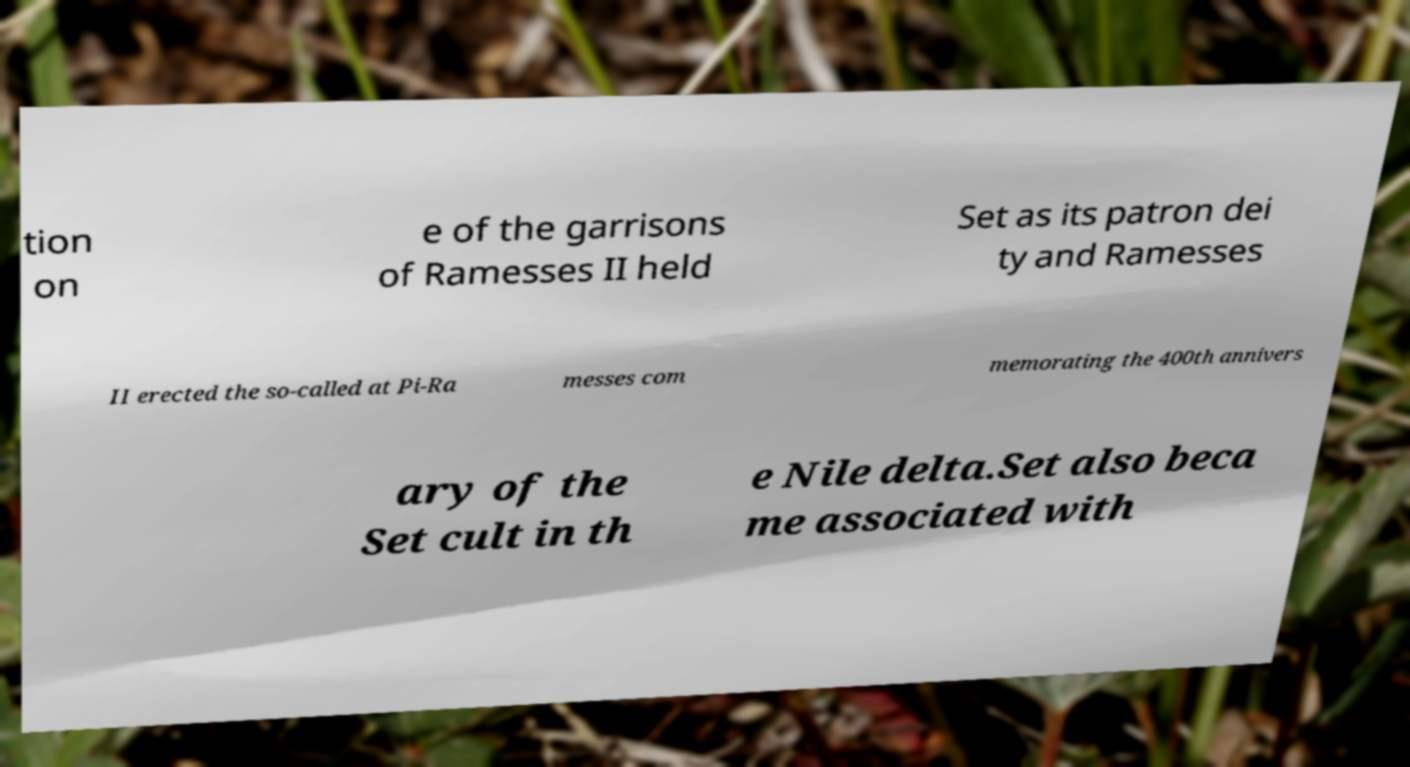Could you extract and type out the text from this image? tion on e of the garrisons of Ramesses II held Set as its patron dei ty and Ramesses II erected the so-called at Pi-Ra messes com memorating the 400th annivers ary of the Set cult in th e Nile delta.Set also beca me associated with 